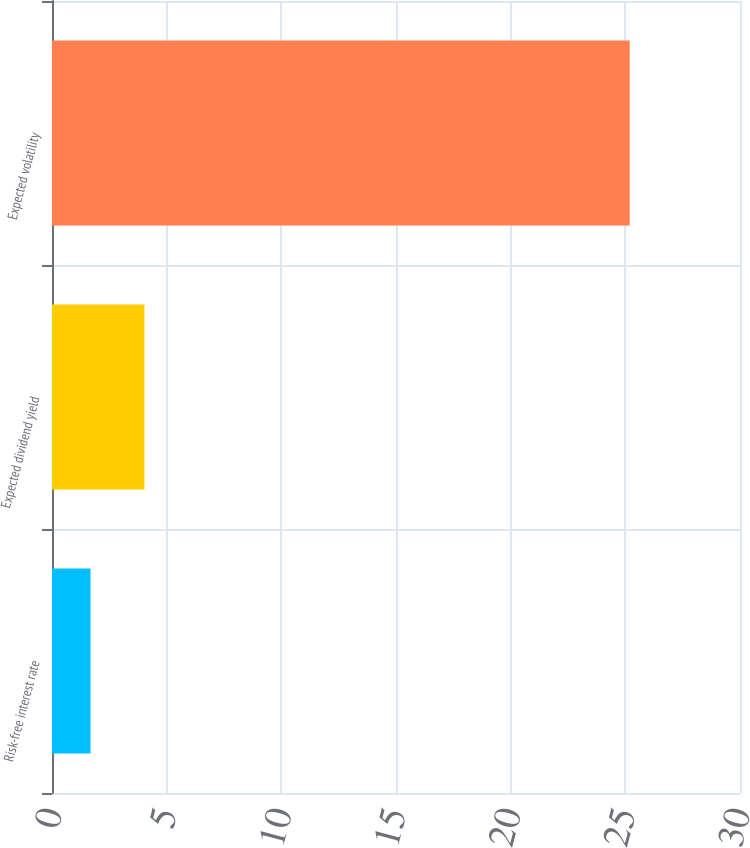<chart> <loc_0><loc_0><loc_500><loc_500><bar_chart><fcel>Risk-free interest rate<fcel>Expected dividend yield<fcel>Expected volatility<nl><fcel>1.68<fcel>4.03<fcel>25.19<nl></chart> 